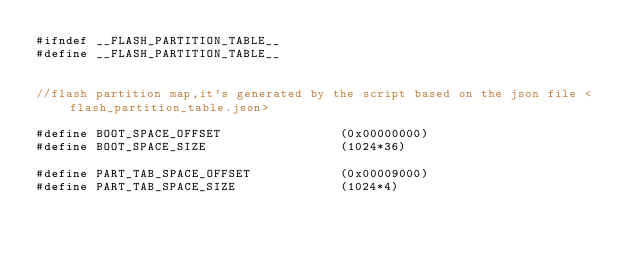Convert code to text. <code><loc_0><loc_0><loc_500><loc_500><_C_>#ifndef __FLASH_PARTITION_TABLE__
#define __FLASH_PARTITION_TABLE__


//flash partition map,it's generated by the script based on the json file <flash_partition_table.json>

#define BOOT_SPACE_OFFSET                (0x00000000)
#define BOOT_SPACE_SIZE                  (1024*36)

#define PART_TAB_SPACE_OFFSET            (0x00009000)
#define PART_TAB_SPACE_SIZE              (1024*4)</code> 